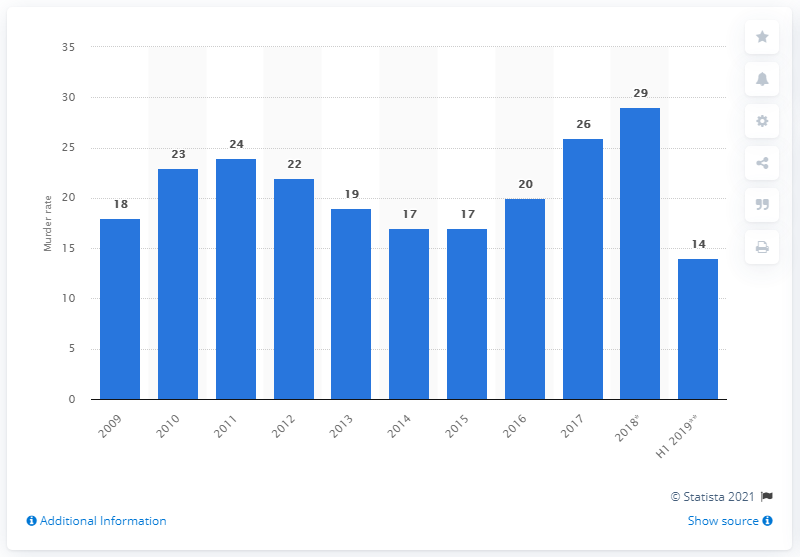Give some essential details in this illustration. During the period of January to June in 2019, the murder rate in Mexico was 14. In 2018, there were approximately 29 people murdered per 100,000 inhabitants in Mexico. Since 2015, Mexico's murder rate has been steadily increasing. 